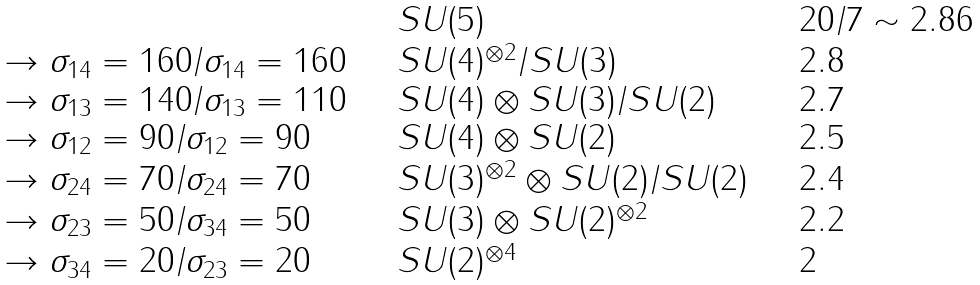<formula> <loc_0><loc_0><loc_500><loc_500>\begin{array} { l l l } & S U ( 5 ) & 2 0 / 7 \sim 2 . 8 6 \\ \rightarrow \sigma _ { 1 4 } = 1 6 0 / \sigma _ { 1 4 } = 1 6 0 \quad & S U ( 4 ) ^ { \otimes 2 } / S U ( 3 ) & 2 . 8 \\ \rightarrow \sigma _ { 1 3 } = 1 4 0 / \sigma _ { 1 3 } = 1 1 0 & S U ( 4 ) \otimes S U ( 3 ) / S U ( 2 ) & 2 . 7 \\ \rightarrow \sigma _ { 1 2 } = 9 0 / \sigma _ { 1 2 } = 9 0 & S U ( 4 ) \otimes S U ( 2 ) & 2 . 5 \\ \rightarrow \sigma _ { 2 4 } = 7 0 / \sigma _ { 2 4 } = 7 0 & S U ( 3 ) ^ { \otimes 2 } \otimes S U ( 2 ) / S U ( 2 ) \quad & 2 . 4 \\ \rightarrow \sigma _ { 2 3 } = 5 0 / \sigma _ { 3 4 } = 5 0 & S U ( 3 ) \otimes S U ( 2 ) ^ { \otimes 2 } & 2 . 2 \\ \rightarrow \sigma _ { 3 4 } = 2 0 / \sigma _ { 2 3 } = 2 0 & S U ( 2 ) ^ { \otimes 4 } & 2 \end{array}</formula> 